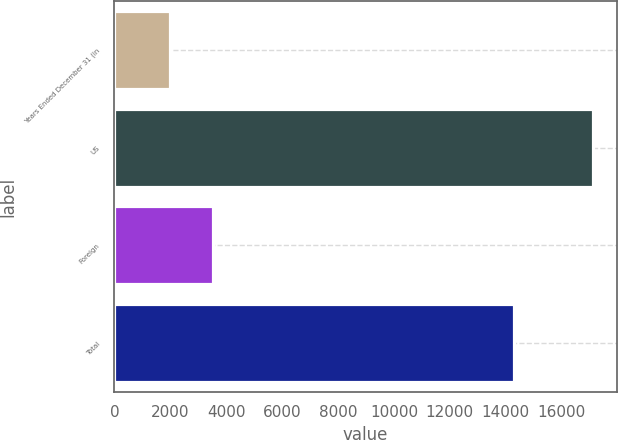<chart> <loc_0><loc_0><loc_500><loc_500><bar_chart><fcel>Years Ended December 31 (in<fcel>US<fcel>Foreign<fcel>Total<nl><fcel>2009<fcel>17122<fcel>3520.3<fcel>14307<nl></chart> 